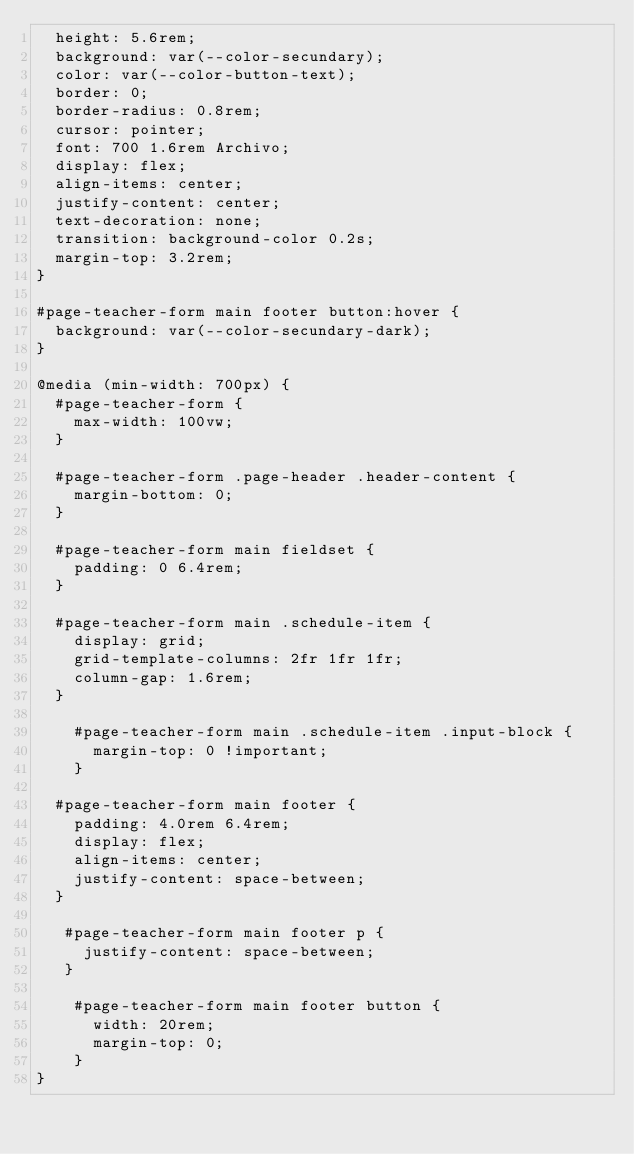<code> <loc_0><loc_0><loc_500><loc_500><_CSS_>  height: 5.6rem;
  background: var(--color-secundary);
  color: var(--color-button-text);
  border: 0;
  border-radius: 0.8rem;
  cursor: pointer;
  font: 700 1.6rem Archivo;
  display: flex;
  align-items: center;
  justify-content: center;
  text-decoration: none;
  transition: background-color 0.2s;
  margin-top: 3.2rem;
}

#page-teacher-form main footer button:hover {
  background: var(--color-secundary-dark);
}

@media (min-width: 700px) {
  #page-teacher-form {
    max-width: 100vw;
  }

  #page-teacher-form .page-header .header-content {
    margin-bottom: 0;
  }

  #page-teacher-form main fieldset {
    padding: 0 6.4rem;
  }

  #page-teacher-form main .schedule-item {
    display: grid;
    grid-template-columns: 2fr 1fr 1fr;
    column-gap: 1.6rem;
  }

    #page-teacher-form main .schedule-item .input-block {
      margin-top: 0 !important;
    }

  #page-teacher-form main footer {
    padding: 4.0rem 6.4rem;
    display: flex;
    align-items: center;
    justify-content: space-between;
  }

   #page-teacher-form main footer p {
     justify-content: space-between;
   }

    #page-teacher-form main footer button {
      width: 20rem;
      margin-top: 0;
    }
}



</code> 